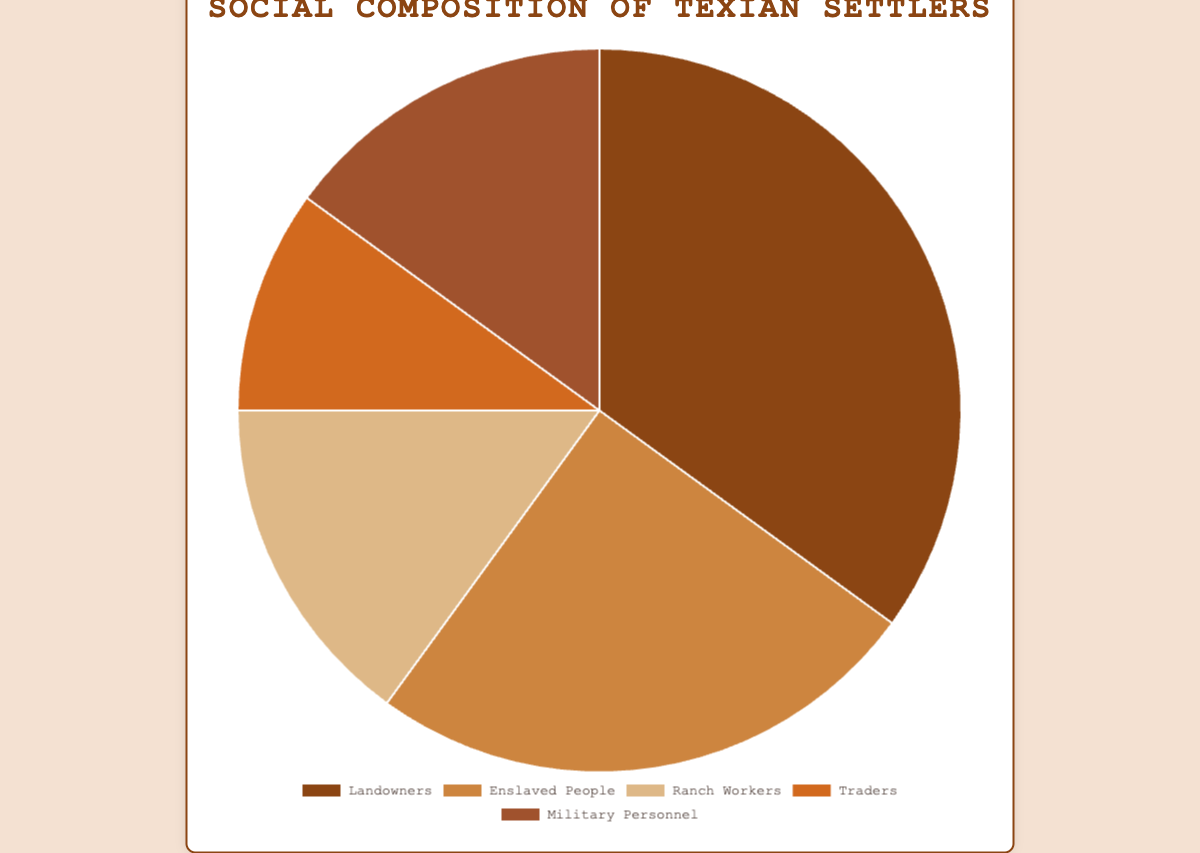Which group is the largest in the social composition of Texian settlers? To find the largest group, refer to the categories and their respective percentages in the figure. Landowners have the highest percentage at 35%.
Answer: Landowners Which two groups have the smallest percentages? To determine the groups with the smallest percentages, look at the percentages provided for each category. Traders and Ranch Workers both have the lowest percentage among the categories, with Traders having 10% and Ranch Workers having 15%.
Answer: Traders and Ranch Workers What is the combined percentage of Military Personnel and Ranch Workers? To find the combined percentage of Military Personnel and Ranch Workers, sum their respective percentages: 15% (Military Personnel) + 15% (Ranch Workers) = 30%.
Answer: 30% How much larger is the percentage of Landowners compared to Traders? Calculate the difference between the percentage of Landowners and Traders: 35% (Landowners) - 10% (Traders) = 25%.
Answer: 25% What is the total percentage of Landowners and Enslaved People combined? Sum the percentages of Landowners and Enslaved People: 35% (Landowners) + 25% (Enslaved People) = 60%.
Answer: 60% Compare the percentage of Enslaved People to Ranch Workers. Which group is larger and by how much? To compare the percentages, subtract the percentage of Ranch Workers from Enslaved People: 25% (Enslaved People) - 15% (Ranch Workers) = 10%.
Answer: Enslaved People, by 10% If you sum the percentages of Traders, Ranch Workers, and Military Personnel, what is the result? Add the percentages of the three groups: 10% (Traders) + 15% (Ranch Workers) + 15% (Military Personnel) = 40%.
Answer: 40% Which group has a percentage that is equal to the combined percentage of Ranch Workers and Traders? First, determine the combined percentage of Ranch Workers and Traders: 15% (Ranch Workers) + 10% (Traders) = 25%. Then, check which group's percentage matches this sum. Enslaved People have a percentage of 25%.
Answer: Enslaved People Describe the color representation for Enslaved People in the pie chart. View the color assigned to Enslaved People in the chart, which is visually distinct and helps in identifying the category. Enslaved People is represented by a tan color.
Answer: tan What is the most common profession among the social composition of Texian settlers? Looking at the chart, the largest percentage represents the most common profession. Landowners have the highest proportion at 35%.
Answer: Landowners 